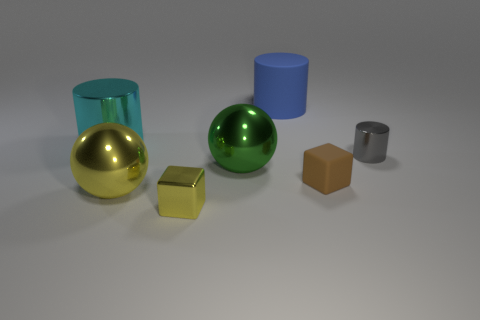Subtract 1 cylinders. How many cylinders are left? 2 Add 2 tiny gray metal balls. How many objects exist? 9 Subtract all gray metal cylinders. How many cylinders are left? 2 Subtract all cylinders. How many objects are left? 4 Subtract all big green matte spheres. Subtract all big green balls. How many objects are left? 6 Add 1 brown matte objects. How many brown matte objects are left? 2 Add 7 yellow cubes. How many yellow cubes exist? 8 Subtract 0 purple cylinders. How many objects are left? 7 